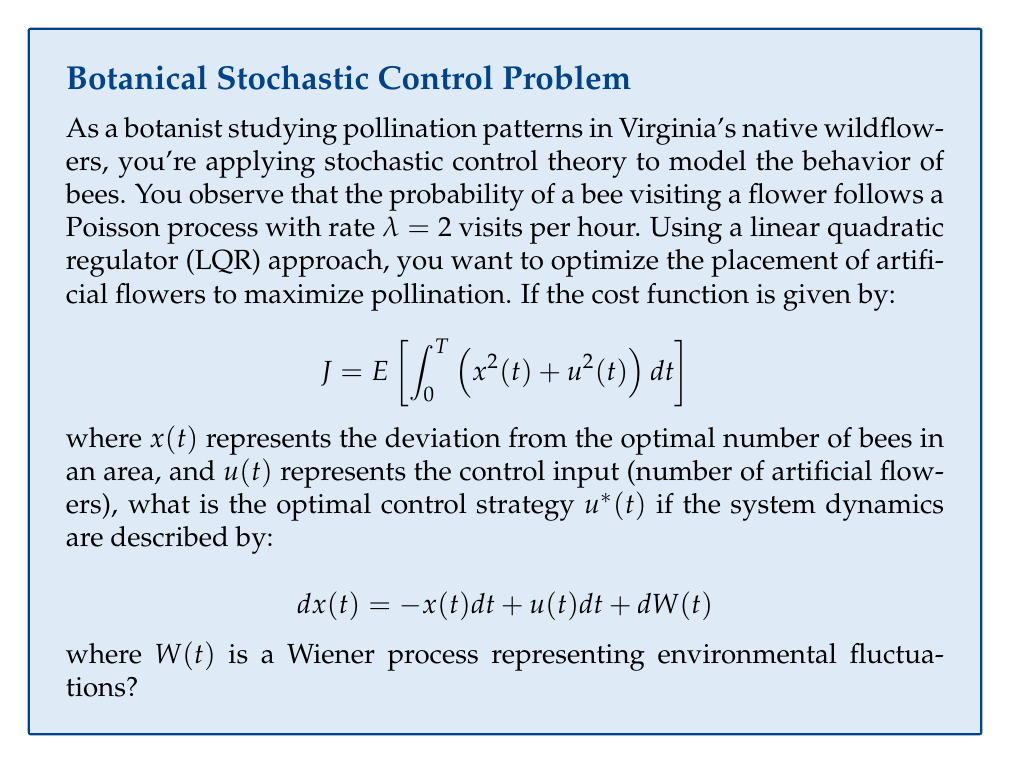Can you answer this question? To solve this problem, we'll use the principles of stochastic optimal control and the Linear Quadratic Regulator (LQR) approach. Here's a step-by-step explanation:

1) The stochastic differential equation (SDE) describing the system dynamics is:

   $$ dx(t) = -x(t)dt + u(t)dt + dW(t) $$

2) The cost function is:

   $$ J = E \left[ \int_0^T \left(x^2(t) + u^2(t)\right) dt \right] $$

3) For an infinite-horizon LQR problem (as T → ∞), the optimal control is given by:

   $$ u^*(t) = -Kx(t) $$

   where K is the feedback gain.

4) The feedback gain K is found by solving the algebraic Riccati equation:

   $$ A^TP + PA - PBR^{-1}B^TP + Q = 0 $$

   where A, B, Q, and R are matrices from the state-space representation of the system and cost function.

5) In our case:
   A = -1 (coefficient of x(t) in the SDE)
   B = 1 (coefficient of u(t) in the SDE)
   Q = 1 (coefficient of x^2(t) in the cost function)
   R = 1 (coefficient of u^2(t) in the cost function)

6) Substituting these values into the Riccati equation:

   $$ (-1)P + P(-1) - P(1)(1)^{-1}(1)P + 1 = 0 $$
   $$ -2P - P^2 + 1 = 0 $$

7) Solving this quadratic equation:

   $$ P^2 + 2P - 1 = 0 $$
   $$ P = \frac{-2 \pm \sqrt{4 + 4}}{2} = -1 \pm \sqrt{2} $$

   We take the positive root: $P = -1 + \sqrt{2}$

8) The optimal feedback gain K is given by:

   $$ K = R^{-1}B^TP = 1 \cdot 1 \cdot (-1 + \sqrt{2}) = -1 + \sqrt{2} $$

9) Therefore, the optimal control strategy is:

   $$ u^*(t) = (-1 + \sqrt{2})x(t) $$

This strategy suggests that the number of artificial flowers should be proportional to the deviation from the optimal number of bees, with a factor of $(-1 + \sqrt{2})$.
Answer: $$ u^*(t) = (-1 + \sqrt{2})x(t) $$ 